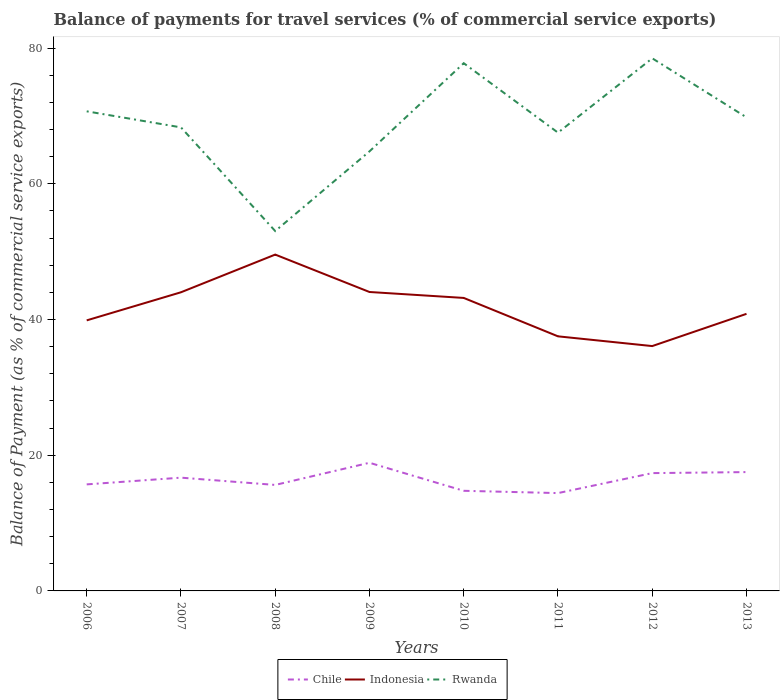How many different coloured lines are there?
Make the answer very short. 3. Is the number of lines equal to the number of legend labels?
Provide a short and direct response. Yes. Across all years, what is the maximum balance of payments for travel services in Indonesia?
Your response must be concise. 36.08. In which year was the balance of payments for travel services in Indonesia maximum?
Provide a succinct answer. 2012. What is the total balance of payments for travel services in Indonesia in the graph?
Ensure brevity in your answer.  7.93. What is the difference between the highest and the second highest balance of payments for travel services in Chile?
Give a very brief answer. 4.47. Is the balance of payments for travel services in Chile strictly greater than the balance of payments for travel services in Rwanda over the years?
Offer a terse response. Yes. How many years are there in the graph?
Provide a succinct answer. 8. Does the graph contain grids?
Ensure brevity in your answer.  No. What is the title of the graph?
Ensure brevity in your answer.  Balance of payments for travel services (% of commercial service exports). Does "Central Europe" appear as one of the legend labels in the graph?
Offer a very short reply. No. What is the label or title of the X-axis?
Your answer should be compact. Years. What is the label or title of the Y-axis?
Provide a short and direct response. Balance of Payment (as % of commercial service exports). What is the Balance of Payment (as % of commercial service exports) in Chile in 2006?
Provide a succinct answer. 15.7. What is the Balance of Payment (as % of commercial service exports) of Indonesia in 2006?
Ensure brevity in your answer.  39.87. What is the Balance of Payment (as % of commercial service exports) of Rwanda in 2006?
Your answer should be very brief. 70.67. What is the Balance of Payment (as % of commercial service exports) in Chile in 2007?
Your answer should be very brief. 16.69. What is the Balance of Payment (as % of commercial service exports) of Indonesia in 2007?
Your answer should be very brief. 44.01. What is the Balance of Payment (as % of commercial service exports) of Rwanda in 2007?
Provide a short and direct response. 68.31. What is the Balance of Payment (as % of commercial service exports) in Chile in 2008?
Offer a terse response. 15.62. What is the Balance of Payment (as % of commercial service exports) in Indonesia in 2008?
Make the answer very short. 49.56. What is the Balance of Payment (as % of commercial service exports) in Rwanda in 2008?
Provide a short and direct response. 53.03. What is the Balance of Payment (as % of commercial service exports) in Chile in 2009?
Provide a succinct answer. 18.88. What is the Balance of Payment (as % of commercial service exports) in Indonesia in 2009?
Provide a short and direct response. 44.05. What is the Balance of Payment (as % of commercial service exports) of Rwanda in 2009?
Provide a short and direct response. 64.77. What is the Balance of Payment (as % of commercial service exports) of Chile in 2010?
Make the answer very short. 14.75. What is the Balance of Payment (as % of commercial service exports) of Indonesia in 2010?
Your answer should be compact. 43.18. What is the Balance of Payment (as % of commercial service exports) of Rwanda in 2010?
Your answer should be very brief. 77.77. What is the Balance of Payment (as % of commercial service exports) of Chile in 2011?
Your response must be concise. 14.42. What is the Balance of Payment (as % of commercial service exports) in Indonesia in 2011?
Give a very brief answer. 37.52. What is the Balance of Payment (as % of commercial service exports) of Rwanda in 2011?
Your answer should be very brief. 67.53. What is the Balance of Payment (as % of commercial service exports) in Chile in 2012?
Your response must be concise. 17.36. What is the Balance of Payment (as % of commercial service exports) in Indonesia in 2012?
Provide a succinct answer. 36.08. What is the Balance of Payment (as % of commercial service exports) in Rwanda in 2012?
Your response must be concise. 78.49. What is the Balance of Payment (as % of commercial service exports) in Chile in 2013?
Provide a succinct answer. 17.51. What is the Balance of Payment (as % of commercial service exports) in Indonesia in 2013?
Your answer should be compact. 40.83. What is the Balance of Payment (as % of commercial service exports) of Rwanda in 2013?
Ensure brevity in your answer.  69.78. Across all years, what is the maximum Balance of Payment (as % of commercial service exports) in Chile?
Your answer should be compact. 18.88. Across all years, what is the maximum Balance of Payment (as % of commercial service exports) in Indonesia?
Offer a terse response. 49.56. Across all years, what is the maximum Balance of Payment (as % of commercial service exports) in Rwanda?
Provide a short and direct response. 78.49. Across all years, what is the minimum Balance of Payment (as % of commercial service exports) of Chile?
Provide a succinct answer. 14.42. Across all years, what is the minimum Balance of Payment (as % of commercial service exports) in Indonesia?
Your answer should be very brief. 36.08. Across all years, what is the minimum Balance of Payment (as % of commercial service exports) in Rwanda?
Provide a succinct answer. 53.03. What is the total Balance of Payment (as % of commercial service exports) in Chile in the graph?
Provide a succinct answer. 130.94. What is the total Balance of Payment (as % of commercial service exports) in Indonesia in the graph?
Offer a terse response. 335.09. What is the total Balance of Payment (as % of commercial service exports) in Rwanda in the graph?
Make the answer very short. 550.35. What is the difference between the Balance of Payment (as % of commercial service exports) in Chile in 2006 and that in 2007?
Offer a very short reply. -0.99. What is the difference between the Balance of Payment (as % of commercial service exports) of Indonesia in 2006 and that in 2007?
Your answer should be very brief. -4.14. What is the difference between the Balance of Payment (as % of commercial service exports) of Rwanda in 2006 and that in 2007?
Your response must be concise. 2.37. What is the difference between the Balance of Payment (as % of commercial service exports) in Chile in 2006 and that in 2008?
Make the answer very short. 0.08. What is the difference between the Balance of Payment (as % of commercial service exports) in Indonesia in 2006 and that in 2008?
Provide a short and direct response. -9.69. What is the difference between the Balance of Payment (as % of commercial service exports) in Rwanda in 2006 and that in 2008?
Make the answer very short. 17.64. What is the difference between the Balance of Payment (as % of commercial service exports) of Chile in 2006 and that in 2009?
Your answer should be very brief. -3.18. What is the difference between the Balance of Payment (as % of commercial service exports) of Indonesia in 2006 and that in 2009?
Offer a terse response. -4.18. What is the difference between the Balance of Payment (as % of commercial service exports) in Rwanda in 2006 and that in 2009?
Give a very brief answer. 5.9. What is the difference between the Balance of Payment (as % of commercial service exports) of Chile in 2006 and that in 2010?
Provide a short and direct response. 0.95. What is the difference between the Balance of Payment (as % of commercial service exports) of Indonesia in 2006 and that in 2010?
Ensure brevity in your answer.  -3.31. What is the difference between the Balance of Payment (as % of commercial service exports) of Rwanda in 2006 and that in 2010?
Make the answer very short. -7.09. What is the difference between the Balance of Payment (as % of commercial service exports) in Chile in 2006 and that in 2011?
Give a very brief answer. 1.28. What is the difference between the Balance of Payment (as % of commercial service exports) of Indonesia in 2006 and that in 2011?
Give a very brief answer. 2.35. What is the difference between the Balance of Payment (as % of commercial service exports) of Rwanda in 2006 and that in 2011?
Ensure brevity in your answer.  3.14. What is the difference between the Balance of Payment (as % of commercial service exports) of Chile in 2006 and that in 2012?
Your answer should be compact. -1.66. What is the difference between the Balance of Payment (as % of commercial service exports) of Indonesia in 2006 and that in 2012?
Offer a very short reply. 3.79. What is the difference between the Balance of Payment (as % of commercial service exports) of Rwanda in 2006 and that in 2012?
Your answer should be very brief. -7.81. What is the difference between the Balance of Payment (as % of commercial service exports) in Chile in 2006 and that in 2013?
Make the answer very short. -1.81. What is the difference between the Balance of Payment (as % of commercial service exports) in Indonesia in 2006 and that in 2013?
Give a very brief answer. -0.96. What is the difference between the Balance of Payment (as % of commercial service exports) of Rwanda in 2006 and that in 2013?
Offer a very short reply. 0.89. What is the difference between the Balance of Payment (as % of commercial service exports) in Chile in 2007 and that in 2008?
Your answer should be very brief. 1.07. What is the difference between the Balance of Payment (as % of commercial service exports) in Indonesia in 2007 and that in 2008?
Provide a short and direct response. -5.55. What is the difference between the Balance of Payment (as % of commercial service exports) of Rwanda in 2007 and that in 2008?
Provide a succinct answer. 15.28. What is the difference between the Balance of Payment (as % of commercial service exports) in Chile in 2007 and that in 2009?
Keep it short and to the point. -2.19. What is the difference between the Balance of Payment (as % of commercial service exports) in Indonesia in 2007 and that in 2009?
Offer a very short reply. -0.04. What is the difference between the Balance of Payment (as % of commercial service exports) in Rwanda in 2007 and that in 2009?
Keep it short and to the point. 3.54. What is the difference between the Balance of Payment (as % of commercial service exports) in Chile in 2007 and that in 2010?
Provide a short and direct response. 1.94. What is the difference between the Balance of Payment (as % of commercial service exports) in Indonesia in 2007 and that in 2010?
Give a very brief answer. 0.83. What is the difference between the Balance of Payment (as % of commercial service exports) of Rwanda in 2007 and that in 2010?
Your answer should be very brief. -9.46. What is the difference between the Balance of Payment (as % of commercial service exports) of Chile in 2007 and that in 2011?
Give a very brief answer. 2.27. What is the difference between the Balance of Payment (as % of commercial service exports) in Indonesia in 2007 and that in 2011?
Offer a very short reply. 6.49. What is the difference between the Balance of Payment (as % of commercial service exports) in Rwanda in 2007 and that in 2011?
Your response must be concise. 0.78. What is the difference between the Balance of Payment (as % of commercial service exports) in Chile in 2007 and that in 2012?
Offer a very short reply. -0.67. What is the difference between the Balance of Payment (as % of commercial service exports) of Indonesia in 2007 and that in 2012?
Provide a succinct answer. 7.93. What is the difference between the Balance of Payment (as % of commercial service exports) in Rwanda in 2007 and that in 2012?
Provide a short and direct response. -10.18. What is the difference between the Balance of Payment (as % of commercial service exports) of Chile in 2007 and that in 2013?
Keep it short and to the point. -0.82. What is the difference between the Balance of Payment (as % of commercial service exports) of Indonesia in 2007 and that in 2013?
Offer a terse response. 3.18. What is the difference between the Balance of Payment (as % of commercial service exports) in Rwanda in 2007 and that in 2013?
Your response must be concise. -1.47. What is the difference between the Balance of Payment (as % of commercial service exports) in Chile in 2008 and that in 2009?
Your answer should be compact. -3.26. What is the difference between the Balance of Payment (as % of commercial service exports) of Indonesia in 2008 and that in 2009?
Your answer should be very brief. 5.51. What is the difference between the Balance of Payment (as % of commercial service exports) in Rwanda in 2008 and that in 2009?
Your response must be concise. -11.74. What is the difference between the Balance of Payment (as % of commercial service exports) of Chile in 2008 and that in 2010?
Offer a very short reply. 0.87. What is the difference between the Balance of Payment (as % of commercial service exports) of Indonesia in 2008 and that in 2010?
Provide a succinct answer. 6.39. What is the difference between the Balance of Payment (as % of commercial service exports) in Rwanda in 2008 and that in 2010?
Your response must be concise. -24.74. What is the difference between the Balance of Payment (as % of commercial service exports) in Chile in 2008 and that in 2011?
Offer a very short reply. 1.2. What is the difference between the Balance of Payment (as % of commercial service exports) in Indonesia in 2008 and that in 2011?
Give a very brief answer. 12.05. What is the difference between the Balance of Payment (as % of commercial service exports) in Rwanda in 2008 and that in 2011?
Your response must be concise. -14.5. What is the difference between the Balance of Payment (as % of commercial service exports) of Chile in 2008 and that in 2012?
Provide a succinct answer. -1.74. What is the difference between the Balance of Payment (as % of commercial service exports) in Indonesia in 2008 and that in 2012?
Your answer should be compact. 13.48. What is the difference between the Balance of Payment (as % of commercial service exports) of Rwanda in 2008 and that in 2012?
Offer a very short reply. -25.46. What is the difference between the Balance of Payment (as % of commercial service exports) in Chile in 2008 and that in 2013?
Your answer should be very brief. -1.89. What is the difference between the Balance of Payment (as % of commercial service exports) in Indonesia in 2008 and that in 2013?
Your response must be concise. 8.73. What is the difference between the Balance of Payment (as % of commercial service exports) of Rwanda in 2008 and that in 2013?
Give a very brief answer. -16.75. What is the difference between the Balance of Payment (as % of commercial service exports) of Chile in 2009 and that in 2010?
Your answer should be very brief. 4.13. What is the difference between the Balance of Payment (as % of commercial service exports) of Indonesia in 2009 and that in 2010?
Your answer should be compact. 0.87. What is the difference between the Balance of Payment (as % of commercial service exports) in Rwanda in 2009 and that in 2010?
Provide a succinct answer. -12.99. What is the difference between the Balance of Payment (as % of commercial service exports) in Chile in 2009 and that in 2011?
Your answer should be compact. 4.47. What is the difference between the Balance of Payment (as % of commercial service exports) of Indonesia in 2009 and that in 2011?
Provide a short and direct response. 6.54. What is the difference between the Balance of Payment (as % of commercial service exports) of Rwanda in 2009 and that in 2011?
Make the answer very short. -2.76. What is the difference between the Balance of Payment (as % of commercial service exports) of Chile in 2009 and that in 2012?
Your answer should be compact. 1.52. What is the difference between the Balance of Payment (as % of commercial service exports) of Indonesia in 2009 and that in 2012?
Ensure brevity in your answer.  7.97. What is the difference between the Balance of Payment (as % of commercial service exports) of Rwanda in 2009 and that in 2012?
Offer a very short reply. -13.71. What is the difference between the Balance of Payment (as % of commercial service exports) of Chile in 2009 and that in 2013?
Your response must be concise. 1.37. What is the difference between the Balance of Payment (as % of commercial service exports) of Indonesia in 2009 and that in 2013?
Make the answer very short. 3.22. What is the difference between the Balance of Payment (as % of commercial service exports) in Rwanda in 2009 and that in 2013?
Provide a succinct answer. -5.01. What is the difference between the Balance of Payment (as % of commercial service exports) in Chile in 2010 and that in 2011?
Your answer should be very brief. 0.34. What is the difference between the Balance of Payment (as % of commercial service exports) of Indonesia in 2010 and that in 2011?
Your response must be concise. 5.66. What is the difference between the Balance of Payment (as % of commercial service exports) in Rwanda in 2010 and that in 2011?
Give a very brief answer. 10.23. What is the difference between the Balance of Payment (as % of commercial service exports) of Chile in 2010 and that in 2012?
Offer a very short reply. -2.61. What is the difference between the Balance of Payment (as % of commercial service exports) in Indonesia in 2010 and that in 2012?
Make the answer very short. 7.1. What is the difference between the Balance of Payment (as % of commercial service exports) in Rwanda in 2010 and that in 2012?
Keep it short and to the point. -0.72. What is the difference between the Balance of Payment (as % of commercial service exports) in Chile in 2010 and that in 2013?
Provide a short and direct response. -2.76. What is the difference between the Balance of Payment (as % of commercial service exports) of Indonesia in 2010 and that in 2013?
Your response must be concise. 2.34. What is the difference between the Balance of Payment (as % of commercial service exports) of Rwanda in 2010 and that in 2013?
Provide a succinct answer. 7.98. What is the difference between the Balance of Payment (as % of commercial service exports) in Chile in 2011 and that in 2012?
Your answer should be very brief. -2.94. What is the difference between the Balance of Payment (as % of commercial service exports) in Indonesia in 2011 and that in 2012?
Make the answer very short. 1.44. What is the difference between the Balance of Payment (as % of commercial service exports) of Rwanda in 2011 and that in 2012?
Give a very brief answer. -10.95. What is the difference between the Balance of Payment (as % of commercial service exports) of Chile in 2011 and that in 2013?
Give a very brief answer. -3.09. What is the difference between the Balance of Payment (as % of commercial service exports) in Indonesia in 2011 and that in 2013?
Give a very brief answer. -3.32. What is the difference between the Balance of Payment (as % of commercial service exports) of Rwanda in 2011 and that in 2013?
Your answer should be compact. -2.25. What is the difference between the Balance of Payment (as % of commercial service exports) in Chile in 2012 and that in 2013?
Ensure brevity in your answer.  -0.15. What is the difference between the Balance of Payment (as % of commercial service exports) of Indonesia in 2012 and that in 2013?
Provide a short and direct response. -4.75. What is the difference between the Balance of Payment (as % of commercial service exports) of Rwanda in 2012 and that in 2013?
Give a very brief answer. 8.7. What is the difference between the Balance of Payment (as % of commercial service exports) in Chile in 2006 and the Balance of Payment (as % of commercial service exports) in Indonesia in 2007?
Your answer should be compact. -28.31. What is the difference between the Balance of Payment (as % of commercial service exports) of Chile in 2006 and the Balance of Payment (as % of commercial service exports) of Rwanda in 2007?
Ensure brevity in your answer.  -52.61. What is the difference between the Balance of Payment (as % of commercial service exports) of Indonesia in 2006 and the Balance of Payment (as % of commercial service exports) of Rwanda in 2007?
Your answer should be very brief. -28.44. What is the difference between the Balance of Payment (as % of commercial service exports) in Chile in 2006 and the Balance of Payment (as % of commercial service exports) in Indonesia in 2008?
Ensure brevity in your answer.  -33.86. What is the difference between the Balance of Payment (as % of commercial service exports) of Chile in 2006 and the Balance of Payment (as % of commercial service exports) of Rwanda in 2008?
Give a very brief answer. -37.33. What is the difference between the Balance of Payment (as % of commercial service exports) of Indonesia in 2006 and the Balance of Payment (as % of commercial service exports) of Rwanda in 2008?
Your response must be concise. -13.16. What is the difference between the Balance of Payment (as % of commercial service exports) of Chile in 2006 and the Balance of Payment (as % of commercial service exports) of Indonesia in 2009?
Offer a very short reply. -28.35. What is the difference between the Balance of Payment (as % of commercial service exports) of Chile in 2006 and the Balance of Payment (as % of commercial service exports) of Rwanda in 2009?
Your response must be concise. -49.07. What is the difference between the Balance of Payment (as % of commercial service exports) of Indonesia in 2006 and the Balance of Payment (as % of commercial service exports) of Rwanda in 2009?
Ensure brevity in your answer.  -24.9. What is the difference between the Balance of Payment (as % of commercial service exports) in Chile in 2006 and the Balance of Payment (as % of commercial service exports) in Indonesia in 2010?
Your answer should be very brief. -27.48. What is the difference between the Balance of Payment (as % of commercial service exports) in Chile in 2006 and the Balance of Payment (as % of commercial service exports) in Rwanda in 2010?
Keep it short and to the point. -62.06. What is the difference between the Balance of Payment (as % of commercial service exports) of Indonesia in 2006 and the Balance of Payment (as % of commercial service exports) of Rwanda in 2010?
Provide a succinct answer. -37.9. What is the difference between the Balance of Payment (as % of commercial service exports) of Chile in 2006 and the Balance of Payment (as % of commercial service exports) of Indonesia in 2011?
Ensure brevity in your answer.  -21.82. What is the difference between the Balance of Payment (as % of commercial service exports) of Chile in 2006 and the Balance of Payment (as % of commercial service exports) of Rwanda in 2011?
Make the answer very short. -51.83. What is the difference between the Balance of Payment (as % of commercial service exports) in Indonesia in 2006 and the Balance of Payment (as % of commercial service exports) in Rwanda in 2011?
Your answer should be compact. -27.66. What is the difference between the Balance of Payment (as % of commercial service exports) of Chile in 2006 and the Balance of Payment (as % of commercial service exports) of Indonesia in 2012?
Your answer should be compact. -20.38. What is the difference between the Balance of Payment (as % of commercial service exports) in Chile in 2006 and the Balance of Payment (as % of commercial service exports) in Rwanda in 2012?
Give a very brief answer. -62.78. What is the difference between the Balance of Payment (as % of commercial service exports) of Indonesia in 2006 and the Balance of Payment (as % of commercial service exports) of Rwanda in 2012?
Provide a succinct answer. -38.62. What is the difference between the Balance of Payment (as % of commercial service exports) of Chile in 2006 and the Balance of Payment (as % of commercial service exports) of Indonesia in 2013?
Provide a short and direct response. -25.13. What is the difference between the Balance of Payment (as % of commercial service exports) of Chile in 2006 and the Balance of Payment (as % of commercial service exports) of Rwanda in 2013?
Ensure brevity in your answer.  -54.08. What is the difference between the Balance of Payment (as % of commercial service exports) of Indonesia in 2006 and the Balance of Payment (as % of commercial service exports) of Rwanda in 2013?
Give a very brief answer. -29.92. What is the difference between the Balance of Payment (as % of commercial service exports) in Chile in 2007 and the Balance of Payment (as % of commercial service exports) in Indonesia in 2008?
Your response must be concise. -32.87. What is the difference between the Balance of Payment (as % of commercial service exports) of Chile in 2007 and the Balance of Payment (as % of commercial service exports) of Rwanda in 2008?
Your response must be concise. -36.34. What is the difference between the Balance of Payment (as % of commercial service exports) in Indonesia in 2007 and the Balance of Payment (as % of commercial service exports) in Rwanda in 2008?
Your response must be concise. -9.02. What is the difference between the Balance of Payment (as % of commercial service exports) in Chile in 2007 and the Balance of Payment (as % of commercial service exports) in Indonesia in 2009?
Offer a very short reply. -27.36. What is the difference between the Balance of Payment (as % of commercial service exports) in Chile in 2007 and the Balance of Payment (as % of commercial service exports) in Rwanda in 2009?
Provide a succinct answer. -48.08. What is the difference between the Balance of Payment (as % of commercial service exports) of Indonesia in 2007 and the Balance of Payment (as % of commercial service exports) of Rwanda in 2009?
Make the answer very short. -20.76. What is the difference between the Balance of Payment (as % of commercial service exports) of Chile in 2007 and the Balance of Payment (as % of commercial service exports) of Indonesia in 2010?
Keep it short and to the point. -26.48. What is the difference between the Balance of Payment (as % of commercial service exports) in Chile in 2007 and the Balance of Payment (as % of commercial service exports) in Rwanda in 2010?
Give a very brief answer. -61.07. What is the difference between the Balance of Payment (as % of commercial service exports) of Indonesia in 2007 and the Balance of Payment (as % of commercial service exports) of Rwanda in 2010?
Give a very brief answer. -33.76. What is the difference between the Balance of Payment (as % of commercial service exports) of Chile in 2007 and the Balance of Payment (as % of commercial service exports) of Indonesia in 2011?
Offer a terse response. -20.82. What is the difference between the Balance of Payment (as % of commercial service exports) of Chile in 2007 and the Balance of Payment (as % of commercial service exports) of Rwanda in 2011?
Keep it short and to the point. -50.84. What is the difference between the Balance of Payment (as % of commercial service exports) of Indonesia in 2007 and the Balance of Payment (as % of commercial service exports) of Rwanda in 2011?
Provide a succinct answer. -23.52. What is the difference between the Balance of Payment (as % of commercial service exports) in Chile in 2007 and the Balance of Payment (as % of commercial service exports) in Indonesia in 2012?
Offer a very short reply. -19.39. What is the difference between the Balance of Payment (as % of commercial service exports) of Chile in 2007 and the Balance of Payment (as % of commercial service exports) of Rwanda in 2012?
Provide a succinct answer. -61.79. What is the difference between the Balance of Payment (as % of commercial service exports) in Indonesia in 2007 and the Balance of Payment (as % of commercial service exports) in Rwanda in 2012?
Provide a short and direct response. -34.48. What is the difference between the Balance of Payment (as % of commercial service exports) of Chile in 2007 and the Balance of Payment (as % of commercial service exports) of Indonesia in 2013?
Give a very brief answer. -24.14. What is the difference between the Balance of Payment (as % of commercial service exports) of Chile in 2007 and the Balance of Payment (as % of commercial service exports) of Rwanda in 2013?
Give a very brief answer. -53.09. What is the difference between the Balance of Payment (as % of commercial service exports) of Indonesia in 2007 and the Balance of Payment (as % of commercial service exports) of Rwanda in 2013?
Offer a very short reply. -25.78. What is the difference between the Balance of Payment (as % of commercial service exports) in Chile in 2008 and the Balance of Payment (as % of commercial service exports) in Indonesia in 2009?
Your answer should be very brief. -28.43. What is the difference between the Balance of Payment (as % of commercial service exports) of Chile in 2008 and the Balance of Payment (as % of commercial service exports) of Rwanda in 2009?
Provide a short and direct response. -49.15. What is the difference between the Balance of Payment (as % of commercial service exports) in Indonesia in 2008 and the Balance of Payment (as % of commercial service exports) in Rwanda in 2009?
Your answer should be very brief. -15.21. What is the difference between the Balance of Payment (as % of commercial service exports) of Chile in 2008 and the Balance of Payment (as % of commercial service exports) of Indonesia in 2010?
Provide a short and direct response. -27.56. What is the difference between the Balance of Payment (as % of commercial service exports) of Chile in 2008 and the Balance of Payment (as % of commercial service exports) of Rwanda in 2010?
Provide a short and direct response. -62.15. What is the difference between the Balance of Payment (as % of commercial service exports) of Indonesia in 2008 and the Balance of Payment (as % of commercial service exports) of Rwanda in 2010?
Your answer should be very brief. -28.2. What is the difference between the Balance of Payment (as % of commercial service exports) of Chile in 2008 and the Balance of Payment (as % of commercial service exports) of Indonesia in 2011?
Your response must be concise. -21.9. What is the difference between the Balance of Payment (as % of commercial service exports) of Chile in 2008 and the Balance of Payment (as % of commercial service exports) of Rwanda in 2011?
Provide a short and direct response. -51.91. What is the difference between the Balance of Payment (as % of commercial service exports) of Indonesia in 2008 and the Balance of Payment (as % of commercial service exports) of Rwanda in 2011?
Ensure brevity in your answer.  -17.97. What is the difference between the Balance of Payment (as % of commercial service exports) of Chile in 2008 and the Balance of Payment (as % of commercial service exports) of Indonesia in 2012?
Your answer should be very brief. -20.46. What is the difference between the Balance of Payment (as % of commercial service exports) in Chile in 2008 and the Balance of Payment (as % of commercial service exports) in Rwanda in 2012?
Offer a terse response. -62.87. What is the difference between the Balance of Payment (as % of commercial service exports) in Indonesia in 2008 and the Balance of Payment (as % of commercial service exports) in Rwanda in 2012?
Provide a succinct answer. -28.92. What is the difference between the Balance of Payment (as % of commercial service exports) in Chile in 2008 and the Balance of Payment (as % of commercial service exports) in Indonesia in 2013?
Your answer should be very brief. -25.21. What is the difference between the Balance of Payment (as % of commercial service exports) of Chile in 2008 and the Balance of Payment (as % of commercial service exports) of Rwanda in 2013?
Your answer should be compact. -54.16. What is the difference between the Balance of Payment (as % of commercial service exports) in Indonesia in 2008 and the Balance of Payment (as % of commercial service exports) in Rwanda in 2013?
Your answer should be very brief. -20.22. What is the difference between the Balance of Payment (as % of commercial service exports) in Chile in 2009 and the Balance of Payment (as % of commercial service exports) in Indonesia in 2010?
Ensure brevity in your answer.  -24.29. What is the difference between the Balance of Payment (as % of commercial service exports) of Chile in 2009 and the Balance of Payment (as % of commercial service exports) of Rwanda in 2010?
Provide a short and direct response. -58.88. What is the difference between the Balance of Payment (as % of commercial service exports) in Indonesia in 2009 and the Balance of Payment (as % of commercial service exports) in Rwanda in 2010?
Offer a very short reply. -33.71. What is the difference between the Balance of Payment (as % of commercial service exports) of Chile in 2009 and the Balance of Payment (as % of commercial service exports) of Indonesia in 2011?
Keep it short and to the point. -18.63. What is the difference between the Balance of Payment (as % of commercial service exports) of Chile in 2009 and the Balance of Payment (as % of commercial service exports) of Rwanda in 2011?
Give a very brief answer. -48.65. What is the difference between the Balance of Payment (as % of commercial service exports) in Indonesia in 2009 and the Balance of Payment (as % of commercial service exports) in Rwanda in 2011?
Your response must be concise. -23.48. What is the difference between the Balance of Payment (as % of commercial service exports) in Chile in 2009 and the Balance of Payment (as % of commercial service exports) in Indonesia in 2012?
Your answer should be very brief. -17.2. What is the difference between the Balance of Payment (as % of commercial service exports) of Chile in 2009 and the Balance of Payment (as % of commercial service exports) of Rwanda in 2012?
Make the answer very short. -59.6. What is the difference between the Balance of Payment (as % of commercial service exports) of Indonesia in 2009 and the Balance of Payment (as % of commercial service exports) of Rwanda in 2012?
Offer a very short reply. -34.43. What is the difference between the Balance of Payment (as % of commercial service exports) in Chile in 2009 and the Balance of Payment (as % of commercial service exports) in Indonesia in 2013?
Offer a very short reply. -21.95. What is the difference between the Balance of Payment (as % of commercial service exports) of Chile in 2009 and the Balance of Payment (as % of commercial service exports) of Rwanda in 2013?
Your response must be concise. -50.9. What is the difference between the Balance of Payment (as % of commercial service exports) in Indonesia in 2009 and the Balance of Payment (as % of commercial service exports) in Rwanda in 2013?
Provide a succinct answer. -25.73. What is the difference between the Balance of Payment (as % of commercial service exports) in Chile in 2010 and the Balance of Payment (as % of commercial service exports) in Indonesia in 2011?
Offer a very short reply. -22.76. What is the difference between the Balance of Payment (as % of commercial service exports) of Chile in 2010 and the Balance of Payment (as % of commercial service exports) of Rwanda in 2011?
Your answer should be compact. -52.78. What is the difference between the Balance of Payment (as % of commercial service exports) of Indonesia in 2010 and the Balance of Payment (as % of commercial service exports) of Rwanda in 2011?
Your answer should be compact. -24.36. What is the difference between the Balance of Payment (as % of commercial service exports) of Chile in 2010 and the Balance of Payment (as % of commercial service exports) of Indonesia in 2012?
Give a very brief answer. -21.33. What is the difference between the Balance of Payment (as % of commercial service exports) in Chile in 2010 and the Balance of Payment (as % of commercial service exports) in Rwanda in 2012?
Keep it short and to the point. -63.73. What is the difference between the Balance of Payment (as % of commercial service exports) in Indonesia in 2010 and the Balance of Payment (as % of commercial service exports) in Rwanda in 2012?
Offer a terse response. -35.31. What is the difference between the Balance of Payment (as % of commercial service exports) in Chile in 2010 and the Balance of Payment (as % of commercial service exports) in Indonesia in 2013?
Make the answer very short. -26.08. What is the difference between the Balance of Payment (as % of commercial service exports) of Chile in 2010 and the Balance of Payment (as % of commercial service exports) of Rwanda in 2013?
Provide a short and direct response. -55.03. What is the difference between the Balance of Payment (as % of commercial service exports) of Indonesia in 2010 and the Balance of Payment (as % of commercial service exports) of Rwanda in 2013?
Give a very brief answer. -26.61. What is the difference between the Balance of Payment (as % of commercial service exports) of Chile in 2011 and the Balance of Payment (as % of commercial service exports) of Indonesia in 2012?
Provide a succinct answer. -21.66. What is the difference between the Balance of Payment (as % of commercial service exports) of Chile in 2011 and the Balance of Payment (as % of commercial service exports) of Rwanda in 2012?
Provide a short and direct response. -64.07. What is the difference between the Balance of Payment (as % of commercial service exports) in Indonesia in 2011 and the Balance of Payment (as % of commercial service exports) in Rwanda in 2012?
Make the answer very short. -40.97. What is the difference between the Balance of Payment (as % of commercial service exports) in Chile in 2011 and the Balance of Payment (as % of commercial service exports) in Indonesia in 2013?
Ensure brevity in your answer.  -26.41. What is the difference between the Balance of Payment (as % of commercial service exports) in Chile in 2011 and the Balance of Payment (as % of commercial service exports) in Rwanda in 2013?
Provide a short and direct response. -55.37. What is the difference between the Balance of Payment (as % of commercial service exports) in Indonesia in 2011 and the Balance of Payment (as % of commercial service exports) in Rwanda in 2013?
Your answer should be very brief. -32.27. What is the difference between the Balance of Payment (as % of commercial service exports) of Chile in 2012 and the Balance of Payment (as % of commercial service exports) of Indonesia in 2013?
Keep it short and to the point. -23.47. What is the difference between the Balance of Payment (as % of commercial service exports) in Chile in 2012 and the Balance of Payment (as % of commercial service exports) in Rwanda in 2013?
Offer a terse response. -52.42. What is the difference between the Balance of Payment (as % of commercial service exports) of Indonesia in 2012 and the Balance of Payment (as % of commercial service exports) of Rwanda in 2013?
Provide a short and direct response. -33.7. What is the average Balance of Payment (as % of commercial service exports) in Chile per year?
Provide a succinct answer. 16.37. What is the average Balance of Payment (as % of commercial service exports) of Indonesia per year?
Offer a terse response. 41.89. What is the average Balance of Payment (as % of commercial service exports) of Rwanda per year?
Provide a succinct answer. 68.79. In the year 2006, what is the difference between the Balance of Payment (as % of commercial service exports) of Chile and Balance of Payment (as % of commercial service exports) of Indonesia?
Offer a very short reply. -24.17. In the year 2006, what is the difference between the Balance of Payment (as % of commercial service exports) in Chile and Balance of Payment (as % of commercial service exports) in Rwanda?
Ensure brevity in your answer.  -54.97. In the year 2006, what is the difference between the Balance of Payment (as % of commercial service exports) in Indonesia and Balance of Payment (as % of commercial service exports) in Rwanda?
Your answer should be compact. -30.81. In the year 2007, what is the difference between the Balance of Payment (as % of commercial service exports) in Chile and Balance of Payment (as % of commercial service exports) in Indonesia?
Provide a succinct answer. -27.32. In the year 2007, what is the difference between the Balance of Payment (as % of commercial service exports) of Chile and Balance of Payment (as % of commercial service exports) of Rwanda?
Provide a succinct answer. -51.62. In the year 2007, what is the difference between the Balance of Payment (as % of commercial service exports) in Indonesia and Balance of Payment (as % of commercial service exports) in Rwanda?
Offer a terse response. -24.3. In the year 2008, what is the difference between the Balance of Payment (as % of commercial service exports) in Chile and Balance of Payment (as % of commercial service exports) in Indonesia?
Your answer should be very brief. -33.94. In the year 2008, what is the difference between the Balance of Payment (as % of commercial service exports) in Chile and Balance of Payment (as % of commercial service exports) in Rwanda?
Offer a very short reply. -37.41. In the year 2008, what is the difference between the Balance of Payment (as % of commercial service exports) in Indonesia and Balance of Payment (as % of commercial service exports) in Rwanda?
Offer a very short reply. -3.47. In the year 2009, what is the difference between the Balance of Payment (as % of commercial service exports) in Chile and Balance of Payment (as % of commercial service exports) in Indonesia?
Your response must be concise. -25.17. In the year 2009, what is the difference between the Balance of Payment (as % of commercial service exports) of Chile and Balance of Payment (as % of commercial service exports) of Rwanda?
Make the answer very short. -45.89. In the year 2009, what is the difference between the Balance of Payment (as % of commercial service exports) of Indonesia and Balance of Payment (as % of commercial service exports) of Rwanda?
Your answer should be compact. -20.72. In the year 2010, what is the difference between the Balance of Payment (as % of commercial service exports) of Chile and Balance of Payment (as % of commercial service exports) of Indonesia?
Make the answer very short. -28.42. In the year 2010, what is the difference between the Balance of Payment (as % of commercial service exports) in Chile and Balance of Payment (as % of commercial service exports) in Rwanda?
Provide a succinct answer. -63.01. In the year 2010, what is the difference between the Balance of Payment (as % of commercial service exports) of Indonesia and Balance of Payment (as % of commercial service exports) of Rwanda?
Keep it short and to the point. -34.59. In the year 2011, what is the difference between the Balance of Payment (as % of commercial service exports) in Chile and Balance of Payment (as % of commercial service exports) in Indonesia?
Ensure brevity in your answer.  -23.1. In the year 2011, what is the difference between the Balance of Payment (as % of commercial service exports) in Chile and Balance of Payment (as % of commercial service exports) in Rwanda?
Provide a succinct answer. -53.12. In the year 2011, what is the difference between the Balance of Payment (as % of commercial service exports) of Indonesia and Balance of Payment (as % of commercial service exports) of Rwanda?
Make the answer very short. -30.02. In the year 2012, what is the difference between the Balance of Payment (as % of commercial service exports) of Chile and Balance of Payment (as % of commercial service exports) of Indonesia?
Ensure brevity in your answer.  -18.72. In the year 2012, what is the difference between the Balance of Payment (as % of commercial service exports) in Chile and Balance of Payment (as % of commercial service exports) in Rwanda?
Offer a terse response. -61.12. In the year 2012, what is the difference between the Balance of Payment (as % of commercial service exports) of Indonesia and Balance of Payment (as % of commercial service exports) of Rwanda?
Your response must be concise. -42.4. In the year 2013, what is the difference between the Balance of Payment (as % of commercial service exports) of Chile and Balance of Payment (as % of commercial service exports) of Indonesia?
Provide a short and direct response. -23.32. In the year 2013, what is the difference between the Balance of Payment (as % of commercial service exports) of Chile and Balance of Payment (as % of commercial service exports) of Rwanda?
Give a very brief answer. -52.27. In the year 2013, what is the difference between the Balance of Payment (as % of commercial service exports) of Indonesia and Balance of Payment (as % of commercial service exports) of Rwanda?
Your answer should be compact. -28.95. What is the ratio of the Balance of Payment (as % of commercial service exports) of Chile in 2006 to that in 2007?
Keep it short and to the point. 0.94. What is the ratio of the Balance of Payment (as % of commercial service exports) of Indonesia in 2006 to that in 2007?
Give a very brief answer. 0.91. What is the ratio of the Balance of Payment (as % of commercial service exports) in Rwanda in 2006 to that in 2007?
Provide a succinct answer. 1.03. What is the ratio of the Balance of Payment (as % of commercial service exports) of Chile in 2006 to that in 2008?
Your response must be concise. 1.01. What is the ratio of the Balance of Payment (as % of commercial service exports) of Indonesia in 2006 to that in 2008?
Make the answer very short. 0.8. What is the ratio of the Balance of Payment (as % of commercial service exports) of Rwanda in 2006 to that in 2008?
Your answer should be compact. 1.33. What is the ratio of the Balance of Payment (as % of commercial service exports) in Chile in 2006 to that in 2009?
Offer a very short reply. 0.83. What is the ratio of the Balance of Payment (as % of commercial service exports) in Indonesia in 2006 to that in 2009?
Your answer should be compact. 0.91. What is the ratio of the Balance of Payment (as % of commercial service exports) of Rwanda in 2006 to that in 2009?
Provide a short and direct response. 1.09. What is the ratio of the Balance of Payment (as % of commercial service exports) of Chile in 2006 to that in 2010?
Offer a very short reply. 1.06. What is the ratio of the Balance of Payment (as % of commercial service exports) of Indonesia in 2006 to that in 2010?
Provide a short and direct response. 0.92. What is the ratio of the Balance of Payment (as % of commercial service exports) of Rwanda in 2006 to that in 2010?
Give a very brief answer. 0.91. What is the ratio of the Balance of Payment (as % of commercial service exports) in Chile in 2006 to that in 2011?
Keep it short and to the point. 1.09. What is the ratio of the Balance of Payment (as % of commercial service exports) of Indonesia in 2006 to that in 2011?
Offer a terse response. 1.06. What is the ratio of the Balance of Payment (as % of commercial service exports) of Rwanda in 2006 to that in 2011?
Your answer should be compact. 1.05. What is the ratio of the Balance of Payment (as % of commercial service exports) of Chile in 2006 to that in 2012?
Your answer should be very brief. 0.9. What is the ratio of the Balance of Payment (as % of commercial service exports) of Indonesia in 2006 to that in 2012?
Your answer should be very brief. 1.1. What is the ratio of the Balance of Payment (as % of commercial service exports) of Rwanda in 2006 to that in 2012?
Offer a very short reply. 0.9. What is the ratio of the Balance of Payment (as % of commercial service exports) in Chile in 2006 to that in 2013?
Your response must be concise. 0.9. What is the ratio of the Balance of Payment (as % of commercial service exports) in Indonesia in 2006 to that in 2013?
Provide a short and direct response. 0.98. What is the ratio of the Balance of Payment (as % of commercial service exports) of Rwanda in 2006 to that in 2013?
Your answer should be very brief. 1.01. What is the ratio of the Balance of Payment (as % of commercial service exports) in Chile in 2007 to that in 2008?
Offer a terse response. 1.07. What is the ratio of the Balance of Payment (as % of commercial service exports) in Indonesia in 2007 to that in 2008?
Your answer should be very brief. 0.89. What is the ratio of the Balance of Payment (as % of commercial service exports) of Rwanda in 2007 to that in 2008?
Your response must be concise. 1.29. What is the ratio of the Balance of Payment (as % of commercial service exports) of Chile in 2007 to that in 2009?
Your answer should be compact. 0.88. What is the ratio of the Balance of Payment (as % of commercial service exports) of Rwanda in 2007 to that in 2009?
Provide a short and direct response. 1.05. What is the ratio of the Balance of Payment (as % of commercial service exports) of Chile in 2007 to that in 2010?
Give a very brief answer. 1.13. What is the ratio of the Balance of Payment (as % of commercial service exports) in Indonesia in 2007 to that in 2010?
Provide a succinct answer. 1.02. What is the ratio of the Balance of Payment (as % of commercial service exports) in Rwanda in 2007 to that in 2010?
Make the answer very short. 0.88. What is the ratio of the Balance of Payment (as % of commercial service exports) in Chile in 2007 to that in 2011?
Provide a succinct answer. 1.16. What is the ratio of the Balance of Payment (as % of commercial service exports) of Indonesia in 2007 to that in 2011?
Ensure brevity in your answer.  1.17. What is the ratio of the Balance of Payment (as % of commercial service exports) in Rwanda in 2007 to that in 2011?
Offer a terse response. 1.01. What is the ratio of the Balance of Payment (as % of commercial service exports) in Chile in 2007 to that in 2012?
Your answer should be very brief. 0.96. What is the ratio of the Balance of Payment (as % of commercial service exports) of Indonesia in 2007 to that in 2012?
Keep it short and to the point. 1.22. What is the ratio of the Balance of Payment (as % of commercial service exports) in Rwanda in 2007 to that in 2012?
Your answer should be very brief. 0.87. What is the ratio of the Balance of Payment (as % of commercial service exports) in Chile in 2007 to that in 2013?
Provide a succinct answer. 0.95. What is the ratio of the Balance of Payment (as % of commercial service exports) in Indonesia in 2007 to that in 2013?
Your response must be concise. 1.08. What is the ratio of the Balance of Payment (as % of commercial service exports) of Rwanda in 2007 to that in 2013?
Keep it short and to the point. 0.98. What is the ratio of the Balance of Payment (as % of commercial service exports) in Chile in 2008 to that in 2009?
Ensure brevity in your answer.  0.83. What is the ratio of the Balance of Payment (as % of commercial service exports) in Indonesia in 2008 to that in 2009?
Give a very brief answer. 1.13. What is the ratio of the Balance of Payment (as % of commercial service exports) of Rwanda in 2008 to that in 2009?
Provide a short and direct response. 0.82. What is the ratio of the Balance of Payment (as % of commercial service exports) of Chile in 2008 to that in 2010?
Keep it short and to the point. 1.06. What is the ratio of the Balance of Payment (as % of commercial service exports) in Indonesia in 2008 to that in 2010?
Your answer should be very brief. 1.15. What is the ratio of the Balance of Payment (as % of commercial service exports) in Rwanda in 2008 to that in 2010?
Give a very brief answer. 0.68. What is the ratio of the Balance of Payment (as % of commercial service exports) in Chile in 2008 to that in 2011?
Keep it short and to the point. 1.08. What is the ratio of the Balance of Payment (as % of commercial service exports) of Indonesia in 2008 to that in 2011?
Give a very brief answer. 1.32. What is the ratio of the Balance of Payment (as % of commercial service exports) in Rwanda in 2008 to that in 2011?
Offer a terse response. 0.79. What is the ratio of the Balance of Payment (as % of commercial service exports) of Chile in 2008 to that in 2012?
Provide a short and direct response. 0.9. What is the ratio of the Balance of Payment (as % of commercial service exports) of Indonesia in 2008 to that in 2012?
Make the answer very short. 1.37. What is the ratio of the Balance of Payment (as % of commercial service exports) of Rwanda in 2008 to that in 2012?
Your answer should be compact. 0.68. What is the ratio of the Balance of Payment (as % of commercial service exports) in Chile in 2008 to that in 2013?
Offer a very short reply. 0.89. What is the ratio of the Balance of Payment (as % of commercial service exports) in Indonesia in 2008 to that in 2013?
Provide a short and direct response. 1.21. What is the ratio of the Balance of Payment (as % of commercial service exports) of Rwanda in 2008 to that in 2013?
Your answer should be very brief. 0.76. What is the ratio of the Balance of Payment (as % of commercial service exports) of Chile in 2009 to that in 2010?
Offer a very short reply. 1.28. What is the ratio of the Balance of Payment (as % of commercial service exports) of Indonesia in 2009 to that in 2010?
Make the answer very short. 1.02. What is the ratio of the Balance of Payment (as % of commercial service exports) in Rwanda in 2009 to that in 2010?
Keep it short and to the point. 0.83. What is the ratio of the Balance of Payment (as % of commercial service exports) in Chile in 2009 to that in 2011?
Give a very brief answer. 1.31. What is the ratio of the Balance of Payment (as % of commercial service exports) of Indonesia in 2009 to that in 2011?
Your answer should be very brief. 1.17. What is the ratio of the Balance of Payment (as % of commercial service exports) in Rwanda in 2009 to that in 2011?
Your response must be concise. 0.96. What is the ratio of the Balance of Payment (as % of commercial service exports) of Chile in 2009 to that in 2012?
Make the answer very short. 1.09. What is the ratio of the Balance of Payment (as % of commercial service exports) in Indonesia in 2009 to that in 2012?
Provide a short and direct response. 1.22. What is the ratio of the Balance of Payment (as % of commercial service exports) in Rwanda in 2009 to that in 2012?
Make the answer very short. 0.83. What is the ratio of the Balance of Payment (as % of commercial service exports) in Chile in 2009 to that in 2013?
Provide a short and direct response. 1.08. What is the ratio of the Balance of Payment (as % of commercial service exports) of Indonesia in 2009 to that in 2013?
Offer a terse response. 1.08. What is the ratio of the Balance of Payment (as % of commercial service exports) in Rwanda in 2009 to that in 2013?
Give a very brief answer. 0.93. What is the ratio of the Balance of Payment (as % of commercial service exports) of Chile in 2010 to that in 2011?
Your response must be concise. 1.02. What is the ratio of the Balance of Payment (as % of commercial service exports) in Indonesia in 2010 to that in 2011?
Offer a very short reply. 1.15. What is the ratio of the Balance of Payment (as % of commercial service exports) of Rwanda in 2010 to that in 2011?
Make the answer very short. 1.15. What is the ratio of the Balance of Payment (as % of commercial service exports) in Chile in 2010 to that in 2012?
Provide a short and direct response. 0.85. What is the ratio of the Balance of Payment (as % of commercial service exports) in Indonesia in 2010 to that in 2012?
Provide a short and direct response. 1.2. What is the ratio of the Balance of Payment (as % of commercial service exports) in Rwanda in 2010 to that in 2012?
Offer a very short reply. 0.99. What is the ratio of the Balance of Payment (as % of commercial service exports) of Chile in 2010 to that in 2013?
Provide a succinct answer. 0.84. What is the ratio of the Balance of Payment (as % of commercial service exports) of Indonesia in 2010 to that in 2013?
Your response must be concise. 1.06. What is the ratio of the Balance of Payment (as % of commercial service exports) of Rwanda in 2010 to that in 2013?
Offer a very short reply. 1.11. What is the ratio of the Balance of Payment (as % of commercial service exports) in Chile in 2011 to that in 2012?
Offer a terse response. 0.83. What is the ratio of the Balance of Payment (as % of commercial service exports) in Indonesia in 2011 to that in 2012?
Provide a short and direct response. 1.04. What is the ratio of the Balance of Payment (as % of commercial service exports) in Rwanda in 2011 to that in 2012?
Your answer should be very brief. 0.86. What is the ratio of the Balance of Payment (as % of commercial service exports) of Chile in 2011 to that in 2013?
Keep it short and to the point. 0.82. What is the ratio of the Balance of Payment (as % of commercial service exports) in Indonesia in 2011 to that in 2013?
Ensure brevity in your answer.  0.92. What is the ratio of the Balance of Payment (as % of commercial service exports) of Rwanda in 2011 to that in 2013?
Provide a succinct answer. 0.97. What is the ratio of the Balance of Payment (as % of commercial service exports) of Indonesia in 2012 to that in 2013?
Offer a terse response. 0.88. What is the ratio of the Balance of Payment (as % of commercial service exports) of Rwanda in 2012 to that in 2013?
Make the answer very short. 1.12. What is the difference between the highest and the second highest Balance of Payment (as % of commercial service exports) in Chile?
Make the answer very short. 1.37. What is the difference between the highest and the second highest Balance of Payment (as % of commercial service exports) of Indonesia?
Your answer should be compact. 5.51. What is the difference between the highest and the second highest Balance of Payment (as % of commercial service exports) of Rwanda?
Provide a succinct answer. 0.72. What is the difference between the highest and the lowest Balance of Payment (as % of commercial service exports) in Chile?
Provide a succinct answer. 4.47. What is the difference between the highest and the lowest Balance of Payment (as % of commercial service exports) of Indonesia?
Your answer should be compact. 13.48. What is the difference between the highest and the lowest Balance of Payment (as % of commercial service exports) of Rwanda?
Your answer should be compact. 25.46. 